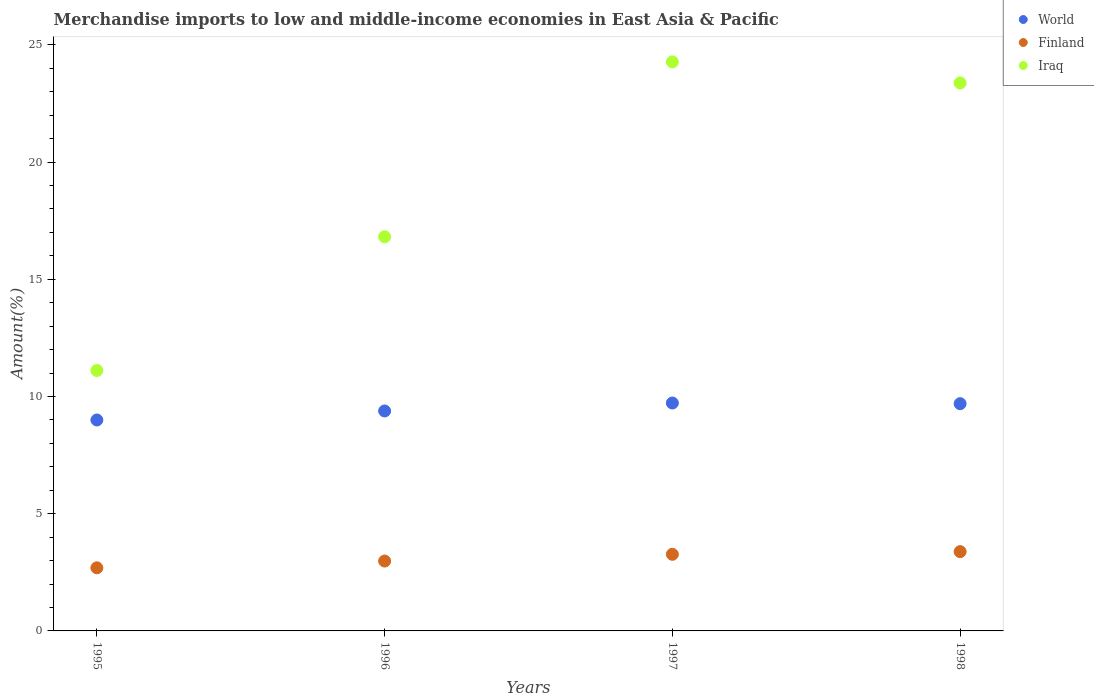How many different coloured dotlines are there?
Ensure brevity in your answer.  3. Is the number of dotlines equal to the number of legend labels?
Provide a short and direct response. Yes. What is the percentage of amount earned from merchandise imports in Finland in 1997?
Give a very brief answer. 3.27. Across all years, what is the maximum percentage of amount earned from merchandise imports in Finland?
Make the answer very short. 3.38. Across all years, what is the minimum percentage of amount earned from merchandise imports in Iraq?
Provide a succinct answer. 11.11. What is the total percentage of amount earned from merchandise imports in Finland in the graph?
Give a very brief answer. 12.32. What is the difference between the percentage of amount earned from merchandise imports in Finland in 1995 and that in 1997?
Make the answer very short. -0.58. What is the difference between the percentage of amount earned from merchandise imports in Finland in 1997 and the percentage of amount earned from merchandise imports in World in 1996?
Provide a succinct answer. -6.11. What is the average percentage of amount earned from merchandise imports in World per year?
Ensure brevity in your answer.  9.45. In the year 1996, what is the difference between the percentage of amount earned from merchandise imports in World and percentage of amount earned from merchandise imports in Iraq?
Keep it short and to the point. -7.43. In how many years, is the percentage of amount earned from merchandise imports in World greater than 12 %?
Provide a short and direct response. 0. What is the ratio of the percentage of amount earned from merchandise imports in World in 1995 to that in 1998?
Offer a terse response. 0.93. What is the difference between the highest and the second highest percentage of amount earned from merchandise imports in World?
Offer a very short reply. 0.03. What is the difference between the highest and the lowest percentage of amount earned from merchandise imports in Finland?
Your answer should be compact. 0.69. How many dotlines are there?
Provide a short and direct response. 3. What is the difference between two consecutive major ticks on the Y-axis?
Provide a short and direct response. 5. Are the values on the major ticks of Y-axis written in scientific E-notation?
Offer a very short reply. No. Does the graph contain grids?
Offer a very short reply. No. Where does the legend appear in the graph?
Offer a terse response. Top right. How many legend labels are there?
Your answer should be very brief. 3. What is the title of the graph?
Your answer should be compact. Merchandise imports to low and middle-income economies in East Asia & Pacific. Does "Serbia" appear as one of the legend labels in the graph?
Your answer should be compact. No. What is the label or title of the X-axis?
Ensure brevity in your answer.  Years. What is the label or title of the Y-axis?
Offer a terse response. Amount(%). What is the Amount(%) of World in 1995?
Give a very brief answer. 9. What is the Amount(%) of Finland in 1995?
Offer a terse response. 2.69. What is the Amount(%) of Iraq in 1995?
Offer a very short reply. 11.11. What is the Amount(%) in World in 1996?
Make the answer very short. 9.38. What is the Amount(%) of Finland in 1996?
Provide a succinct answer. 2.98. What is the Amount(%) of Iraq in 1996?
Provide a short and direct response. 16.81. What is the Amount(%) in World in 1997?
Your answer should be compact. 9.72. What is the Amount(%) in Finland in 1997?
Provide a short and direct response. 3.27. What is the Amount(%) in Iraq in 1997?
Ensure brevity in your answer.  24.27. What is the Amount(%) of World in 1998?
Keep it short and to the point. 9.69. What is the Amount(%) of Finland in 1998?
Offer a very short reply. 3.38. What is the Amount(%) in Iraq in 1998?
Keep it short and to the point. 23.37. Across all years, what is the maximum Amount(%) in World?
Offer a very short reply. 9.72. Across all years, what is the maximum Amount(%) of Finland?
Provide a short and direct response. 3.38. Across all years, what is the maximum Amount(%) of Iraq?
Provide a succinct answer. 24.27. Across all years, what is the minimum Amount(%) in World?
Keep it short and to the point. 9. Across all years, what is the minimum Amount(%) in Finland?
Make the answer very short. 2.69. Across all years, what is the minimum Amount(%) of Iraq?
Provide a short and direct response. 11.11. What is the total Amount(%) in World in the graph?
Keep it short and to the point. 37.79. What is the total Amount(%) of Finland in the graph?
Give a very brief answer. 12.32. What is the total Amount(%) of Iraq in the graph?
Offer a very short reply. 75.56. What is the difference between the Amount(%) in World in 1995 and that in 1996?
Provide a succinct answer. -0.38. What is the difference between the Amount(%) of Finland in 1995 and that in 1996?
Offer a very short reply. -0.29. What is the difference between the Amount(%) of Iraq in 1995 and that in 1996?
Keep it short and to the point. -5.7. What is the difference between the Amount(%) in World in 1995 and that in 1997?
Offer a very short reply. -0.72. What is the difference between the Amount(%) of Finland in 1995 and that in 1997?
Provide a succinct answer. -0.58. What is the difference between the Amount(%) of Iraq in 1995 and that in 1997?
Your response must be concise. -13.16. What is the difference between the Amount(%) in World in 1995 and that in 1998?
Provide a short and direct response. -0.7. What is the difference between the Amount(%) in Finland in 1995 and that in 1998?
Keep it short and to the point. -0.69. What is the difference between the Amount(%) of Iraq in 1995 and that in 1998?
Your response must be concise. -12.26. What is the difference between the Amount(%) of World in 1996 and that in 1997?
Provide a succinct answer. -0.34. What is the difference between the Amount(%) of Finland in 1996 and that in 1997?
Offer a terse response. -0.29. What is the difference between the Amount(%) in Iraq in 1996 and that in 1997?
Provide a succinct answer. -7.46. What is the difference between the Amount(%) in World in 1996 and that in 1998?
Make the answer very short. -0.31. What is the difference between the Amount(%) in Finland in 1996 and that in 1998?
Ensure brevity in your answer.  -0.4. What is the difference between the Amount(%) in Iraq in 1996 and that in 1998?
Ensure brevity in your answer.  -6.56. What is the difference between the Amount(%) of World in 1997 and that in 1998?
Keep it short and to the point. 0.03. What is the difference between the Amount(%) of Finland in 1997 and that in 1998?
Offer a terse response. -0.11. What is the difference between the Amount(%) in Iraq in 1997 and that in 1998?
Your answer should be compact. 0.9. What is the difference between the Amount(%) of World in 1995 and the Amount(%) of Finland in 1996?
Your answer should be very brief. 6.02. What is the difference between the Amount(%) of World in 1995 and the Amount(%) of Iraq in 1996?
Offer a very short reply. -7.81. What is the difference between the Amount(%) in Finland in 1995 and the Amount(%) in Iraq in 1996?
Give a very brief answer. -14.12. What is the difference between the Amount(%) of World in 1995 and the Amount(%) of Finland in 1997?
Your answer should be very brief. 5.73. What is the difference between the Amount(%) in World in 1995 and the Amount(%) in Iraq in 1997?
Ensure brevity in your answer.  -15.27. What is the difference between the Amount(%) of Finland in 1995 and the Amount(%) of Iraq in 1997?
Provide a succinct answer. -21.58. What is the difference between the Amount(%) of World in 1995 and the Amount(%) of Finland in 1998?
Make the answer very short. 5.62. What is the difference between the Amount(%) in World in 1995 and the Amount(%) in Iraq in 1998?
Provide a short and direct response. -14.37. What is the difference between the Amount(%) in Finland in 1995 and the Amount(%) in Iraq in 1998?
Give a very brief answer. -20.68. What is the difference between the Amount(%) of World in 1996 and the Amount(%) of Finland in 1997?
Make the answer very short. 6.11. What is the difference between the Amount(%) in World in 1996 and the Amount(%) in Iraq in 1997?
Your answer should be compact. -14.89. What is the difference between the Amount(%) in Finland in 1996 and the Amount(%) in Iraq in 1997?
Make the answer very short. -21.29. What is the difference between the Amount(%) in World in 1996 and the Amount(%) in Finland in 1998?
Offer a terse response. 6. What is the difference between the Amount(%) in World in 1996 and the Amount(%) in Iraq in 1998?
Provide a short and direct response. -13.99. What is the difference between the Amount(%) in Finland in 1996 and the Amount(%) in Iraq in 1998?
Provide a succinct answer. -20.39. What is the difference between the Amount(%) in World in 1997 and the Amount(%) in Finland in 1998?
Provide a short and direct response. 6.34. What is the difference between the Amount(%) in World in 1997 and the Amount(%) in Iraq in 1998?
Your response must be concise. -13.65. What is the difference between the Amount(%) in Finland in 1997 and the Amount(%) in Iraq in 1998?
Provide a short and direct response. -20.1. What is the average Amount(%) in World per year?
Provide a short and direct response. 9.45. What is the average Amount(%) in Finland per year?
Provide a short and direct response. 3.08. What is the average Amount(%) in Iraq per year?
Provide a short and direct response. 18.89. In the year 1995, what is the difference between the Amount(%) of World and Amount(%) of Finland?
Ensure brevity in your answer.  6.31. In the year 1995, what is the difference between the Amount(%) of World and Amount(%) of Iraq?
Provide a succinct answer. -2.11. In the year 1995, what is the difference between the Amount(%) in Finland and Amount(%) in Iraq?
Give a very brief answer. -8.42. In the year 1996, what is the difference between the Amount(%) of World and Amount(%) of Finland?
Provide a short and direct response. 6.4. In the year 1996, what is the difference between the Amount(%) in World and Amount(%) in Iraq?
Provide a succinct answer. -7.43. In the year 1996, what is the difference between the Amount(%) of Finland and Amount(%) of Iraq?
Your answer should be compact. -13.83. In the year 1997, what is the difference between the Amount(%) in World and Amount(%) in Finland?
Keep it short and to the point. 6.45. In the year 1997, what is the difference between the Amount(%) of World and Amount(%) of Iraq?
Ensure brevity in your answer.  -14.55. In the year 1997, what is the difference between the Amount(%) in Finland and Amount(%) in Iraq?
Offer a very short reply. -21. In the year 1998, what is the difference between the Amount(%) in World and Amount(%) in Finland?
Your response must be concise. 6.31. In the year 1998, what is the difference between the Amount(%) of World and Amount(%) of Iraq?
Give a very brief answer. -13.68. In the year 1998, what is the difference between the Amount(%) of Finland and Amount(%) of Iraq?
Offer a very short reply. -19.99. What is the ratio of the Amount(%) of World in 1995 to that in 1996?
Provide a succinct answer. 0.96. What is the ratio of the Amount(%) of Finland in 1995 to that in 1996?
Your response must be concise. 0.9. What is the ratio of the Amount(%) in Iraq in 1995 to that in 1996?
Your answer should be very brief. 0.66. What is the ratio of the Amount(%) of World in 1995 to that in 1997?
Your answer should be very brief. 0.93. What is the ratio of the Amount(%) of Finland in 1995 to that in 1997?
Keep it short and to the point. 0.82. What is the ratio of the Amount(%) of Iraq in 1995 to that in 1997?
Your response must be concise. 0.46. What is the ratio of the Amount(%) in World in 1995 to that in 1998?
Provide a short and direct response. 0.93. What is the ratio of the Amount(%) in Finland in 1995 to that in 1998?
Ensure brevity in your answer.  0.8. What is the ratio of the Amount(%) of Iraq in 1995 to that in 1998?
Ensure brevity in your answer.  0.48. What is the ratio of the Amount(%) of Finland in 1996 to that in 1997?
Make the answer very short. 0.91. What is the ratio of the Amount(%) of Iraq in 1996 to that in 1997?
Your answer should be compact. 0.69. What is the ratio of the Amount(%) of World in 1996 to that in 1998?
Provide a succinct answer. 0.97. What is the ratio of the Amount(%) of Finland in 1996 to that in 1998?
Make the answer very short. 0.88. What is the ratio of the Amount(%) in Iraq in 1996 to that in 1998?
Your response must be concise. 0.72. What is the ratio of the Amount(%) in Finland in 1997 to that in 1998?
Your answer should be compact. 0.97. What is the difference between the highest and the second highest Amount(%) of World?
Keep it short and to the point. 0.03. What is the difference between the highest and the second highest Amount(%) in Finland?
Keep it short and to the point. 0.11. What is the difference between the highest and the second highest Amount(%) of Iraq?
Give a very brief answer. 0.9. What is the difference between the highest and the lowest Amount(%) of World?
Keep it short and to the point. 0.72. What is the difference between the highest and the lowest Amount(%) in Finland?
Give a very brief answer. 0.69. What is the difference between the highest and the lowest Amount(%) in Iraq?
Make the answer very short. 13.16. 